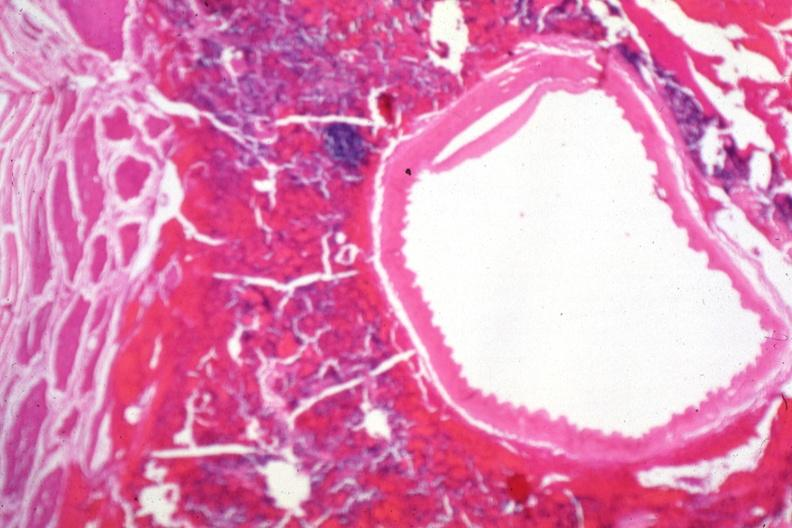what is present?
Answer the question using a single word or phrase. Endocrine 